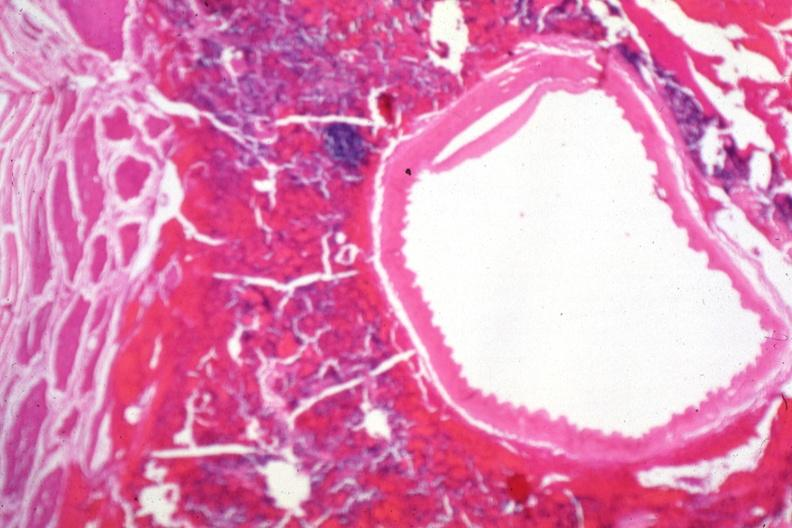what is present?
Answer the question using a single word or phrase. Endocrine 